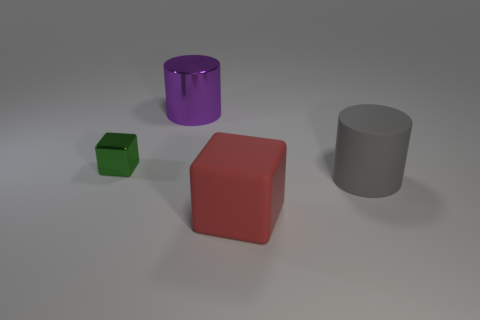Add 1 green objects. How many objects exist? 5 Subtract all tiny green shiny objects. Subtract all big rubber cylinders. How many objects are left? 2 Add 1 large gray cylinders. How many large gray cylinders are left? 2 Add 3 big rubber cylinders. How many big rubber cylinders exist? 4 Subtract 0 brown balls. How many objects are left? 4 